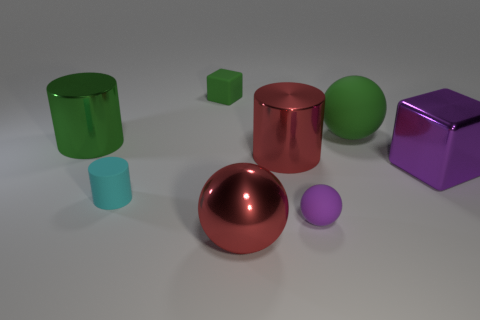Subtract 1 cylinders. How many cylinders are left? 2 Add 2 big rubber things. How many objects exist? 10 Subtract all spheres. How many objects are left? 5 Add 2 red balls. How many red balls are left? 3 Add 5 purple metal balls. How many purple metal balls exist? 5 Subtract 1 green blocks. How many objects are left? 7 Subtract all large shiny cylinders. Subtract all red things. How many objects are left? 4 